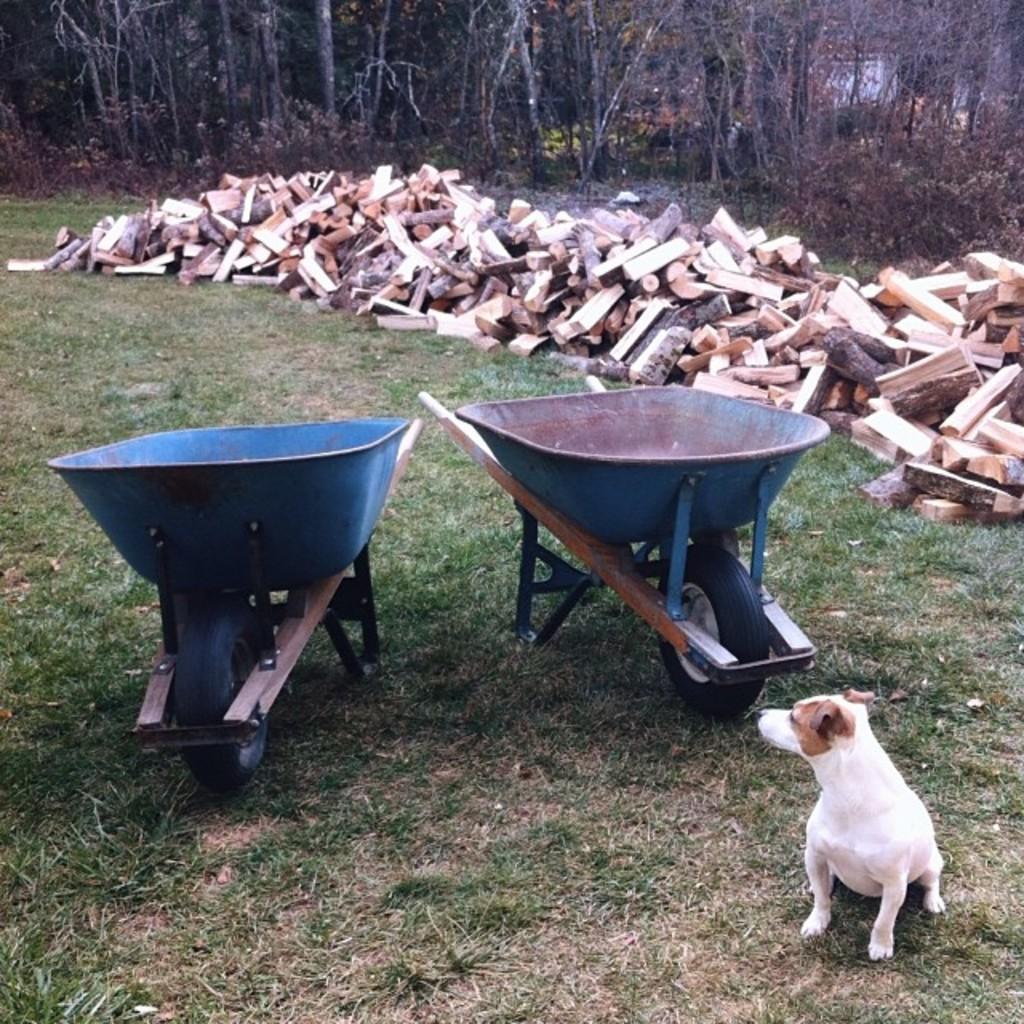Can you describe this image briefly? In the image on the ground there are two wheelbarrows. In front of them there is a puppy sitting on the ground. On the ground there is grass. Behind them there are wooden pieces on the ground. In the background there are trees. 